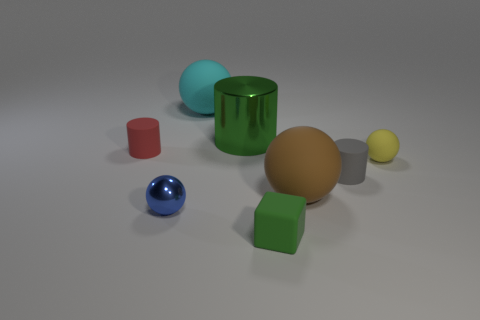Subtract all green balls. Subtract all green cylinders. How many balls are left? 4 Add 2 green metal objects. How many objects exist? 10 Subtract all cylinders. How many objects are left? 5 Subtract 0 cyan cylinders. How many objects are left? 8 Subtract all red matte objects. Subtract all tiny gray matte cylinders. How many objects are left? 6 Add 7 small blue shiny balls. How many small blue shiny balls are left? 8 Add 8 purple cylinders. How many purple cylinders exist? 8 